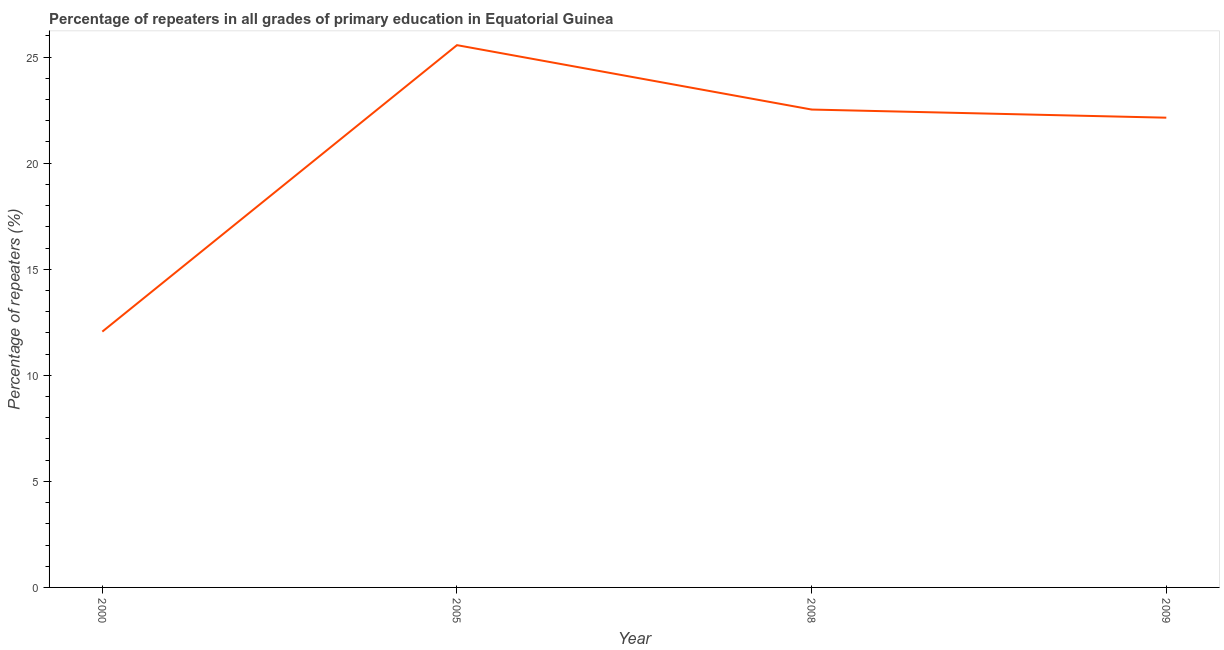What is the percentage of repeaters in primary education in 2005?
Ensure brevity in your answer.  25.56. Across all years, what is the maximum percentage of repeaters in primary education?
Offer a terse response. 25.56. Across all years, what is the minimum percentage of repeaters in primary education?
Provide a succinct answer. 12.06. What is the sum of the percentage of repeaters in primary education?
Give a very brief answer. 82.3. What is the difference between the percentage of repeaters in primary education in 2000 and 2009?
Offer a very short reply. -10.09. What is the average percentage of repeaters in primary education per year?
Make the answer very short. 20.57. What is the median percentage of repeaters in primary education?
Ensure brevity in your answer.  22.34. Do a majority of the years between 2009 and 2005 (inclusive) have percentage of repeaters in primary education greater than 14 %?
Your response must be concise. No. What is the ratio of the percentage of repeaters in primary education in 2008 to that in 2009?
Provide a short and direct response. 1.02. Is the percentage of repeaters in primary education in 2000 less than that in 2009?
Keep it short and to the point. Yes. Is the difference between the percentage of repeaters in primary education in 2005 and 2008 greater than the difference between any two years?
Offer a very short reply. No. What is the difference between the highest and the second highest percentage of repeaters in primary education?
Make the answer very short. 3.04. What is the difference between the highest and the lowest percentage of repeaters in primary education?
Make the answer very short. 13.5. In how many years, is the percentage of repeaters in primary education greater than the average percentage of repeaters in primary education taken over all years?
Your response must be concise. 3. Does the percentage of repeaters in primary education monotonically increase over the years?
Provide a short and direct response. No. How many lines are there?
Provide a succinct answer. 1. What is the title of the graph?
Give a very brief answer. Percentage of repeaters in all grades of primary education in Equatorial Guinea. What is the label or title of the X-axis?
Keep it short and to the point. Year. What is the label or title of the Y-axis?
Provide a short and direct response. Percentage of repeaters (%). What is the Percentage of repeaters (%) in 2000?
Ensure brevity in your answer.  12.06. What is the Percentage of repeaters (%) in 2005?
Make the answer very short. 25.56. What is the Percentage of repeaters (%) in 2008?
Your answer should be compact. 22.53. What is the Percentage of repeaters (%) in 2009?
Provide a short and direct response. 22.14. What is the difference between the Percentage of repeaters (%) in 2000 and 2005?
Keep it short and to the point. -13.5. What is the difference between the Percentage of repeaters (%) in 2000 and 2008?
Provide a short and direct response. -10.47. What is the difference between the Percentage of repeaters (%) in 2000 and 2009?
Your answer should be very brief. -10.09. What is the difference between the Percentage of repeaters (%) in 2005 and 2008?
Offer a terse response. 3.04. What is the difference between the Percentage of repeaters (%) in 2005 and 2009?
Offer a terse response. 3.42. What is the difference between the Percentage of repeaters (%) in 2008 and 2009?
Your answer should be compact. 0.38. What is the ratio of the Percentage of repeaters (%) in 2000 to that in 2005?
Provide a succinct answer. 0.47. What is the ratio of the Percentage of repeaters (%) in 2000 to that in 2008?
Your answer should be compact. 0.54. What is the ratio of the Percentage of repeaters (%) in 2000 to that in 2009?
Provide a short and direct response. 0.55. What is the ratio of the Percentage of repeaters (%) in 2005 to that in 2008?
Offer a very short reply. 1.14. What is the ratio of the Percentage of repeaters (%) in 2005 to that in 2009?
Ensure brevity in your answer.  1.15. 